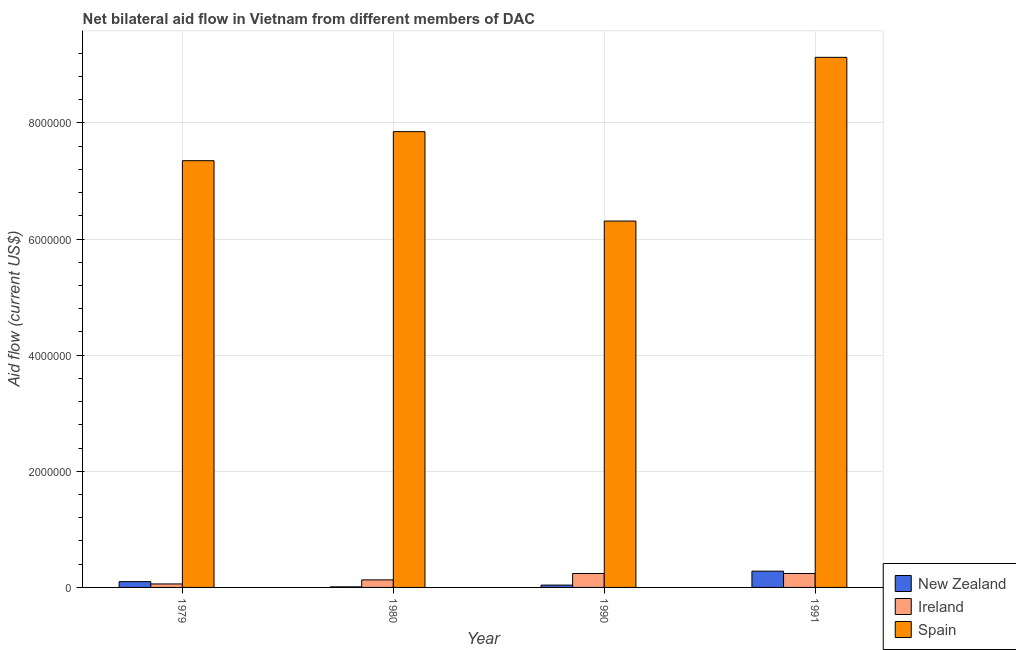What is the label of the 1st group of bars from the left?
Ensure brevity in your answer.  1979. In how many cases, is the number of bars for a given year not equal to the number of legend labels?
Your answer should be very brief. 0. What is the amount of aid provided by new zealand in 1979?
Provide a short and direct response. 1.00e+05. Across all years, what is the maximum amount of aid provided by ireland?
Give a very brief answer. 2.40e+05. Across all years, what is the minimum amount of aid provided by new zealand?
Provide a short and direct response. 10000. In which year was the amount of aid provided by spain minimum?
Offer a very short reply. 1990. What is the total amount of aid provided by ireland in the graph?
Your answer should be compact. 6.70e+05. What is the difference between the amount of aid provided by spain in 1990 and that in 1991?
Ensure brevity in your answer.  -2.82e+06. What is the difference between the amount of aid provided by new zealand in 1980 and the amount of aid provided by ireland in 1990?
Make the answer very short. -3.00e+04. What is the average amount of aid provided by ireland per year?
Offer a terse response. 1.68e+05. In how many years, is the amount of aid provided by ireland greater than 4000000 US$?
Make the answer very short. 0. Is the difference between the amount of aid provided by spain in 1979 and 1980 greater than the difference between the amount of aid provided by ireland in 1979 and 1980?
Offer a very short reply. No. What is the difference between the highest and the second highest amount of aid provided by ireland?
Your answer should be very brief. 0. What is the difference between the highest and the lowest amount of aid provided by spain?
Your answer should be very brief. 2.82e+06. What does the 2nd bar from the left in 1980 represents?
Your response must be concise. Ireland. What does the 2nd bar from the right in 1979 represents?
Ensure brevity in your answer.  Ireland. Is it the case that in every year, the sum of the amount of aid provided by new zealand and amount of aid provided by ireland is greater than the amount of aid provided by spain?
Offer a terse response. No. Are all the bars in the graph horizontal?
Provide a succinct answer. No. Are the values on the major ticks of Y-axis written in scientific E-notation?
Provide a short and direct response. No. Does the graph contain any zero values?
Your answer should be very brief. No. Where does the legend appear in the graph?
Your answer should be very brief. Bottom right. How are the legend labels stacked?
Your answer should be compact. Vertical. What is the title of the graph?
Ensure brevity in your answer.  Net bilateral aid flow in Vietnam from different members of DAC. Does "Social Protection" appear as one of the legend labels in the graph?
Give a very brief answer. No. What is the label or title of the X-axis?
Your answer should be very brief. Year. What is the Aid flow (current US$) of Ireland in 1979?
Offer a terse response. 6.00e+04. What is the Aid flow (current US$) in Spain in 1979?
Offer a very short reply. 7.35e+06. What is the Aid flow (current US$) in Spain in 1980?
Your answer should be compact. 7.85e+06. What is the Aid flow (current US$) of Ireland in 1990?
Offer a very short reply. 2.40e+05. What is the Aid flow (current US$) of Spain in 1990?
Your response must be concise. 6.31e+06. What is the Aid flow (current US$) of New Zealand in 1991?
Give a very brief answer. 2.80e+05. What is the Aid flow (current US$) of Ireland in 1991?
Offer a terse response. 2.40e+05. What is the Aid flow (current US$) of Spain in 1991?
Provide a succinct answer. 9.13e+06. Across all years, what is the maximum Aid flow (current US$) of New Zealand?
Offer a very short reply. 2.80e+05. Across all years, what is the maximum Aid flow (current US$) in Ireland?
Your answer should be compact. 2.40e+05. Across all years, what is the maximum Aid flow (current US$) of Spain?
Provide a short and direct response. 9.13e+06. Across all years, what is the minimum Aid flow (current US$) of Spain?
Make the answer very short. 6.31e+06. What is the total Aid flow (current US$) of Ireland in the graph?
Ensure brevity in your answer.  6.70e+05. What is the total Aid flow (current US$) in Spain in the graph?
Your answer should be compact. 3.06e+07. What is the difference between the Aid flow (current US$) of Spain in 1979 and that in 1980?
Offer a terse response. -5.00e+05. What is the difference between the Aid flow (current US$) in New Zealand in 1979 and that in 1990?
Provide a succinct answer. 6.00e+04. What is the difference between the Aid flow (current US$) of Spain in 1979 and that in 1990?
Offer a very short reply. 1.04e+06. What is the difference between the Aid flow (current US$) in Spain in 1979 and that in 1991?
Keep it short and to the point. -1.78e+06. What is the difference between the Aid flow (current US$) in Ireland in 1980 and that in 1990?
Make the answer very short. -1.10e+05. What is the difference between the Aid flow (current US$) of Spain in 1980 and that in 1990?
Offer a terse response. 1.54e+06. What is the difference between the Aid flow (current US$) in New Zealand in 1980 and that in 1991?
Your response must be concise. -2.70e+05. What is the difference between the Aid flow (current US$) in Ireland in 1980 and that in 1991?
Make the answer very short. -1.10e+05. What is the difference between the Aid flow (current US$) of Spain in 1980 and that in 1991?
Your answer should be very brief. -1.28e+06. What is the difference between the Aid flow (current US$) of Spain in 1990 and that in 1991?
Make the answer very short. -2.82e+06. What is the difference between the Aid flow (current US$) of New Zealand in 1979 and the Aid flow (current US$) of Spain in 1980?
Your answer should be compact. -7.75e+06. What is the difference between the Aid flow (current US$) in Ireland in 1979 and the Aid flow (current US$) in Spain in 1980?
Provide a succinct answer. -7.79e+06. What is the difference between the Aid flow (current US$) of New Zealand in 1979 and the Aid flow (current US$) of Spain in 1990?
Offer a very short reply. -6.21e+06. What is the difference between the Aid flow (current US$) in Ireland in 1979 and the Aid flow (current US$) in Spain in 1990?
Keep it short and to the point. -6.25e+06. What is the difference between the Aid flow (current US$) of New Zealand in 1979 and the Aid flow (current US$) of Spain in 1991?
Provide a short and direct response. -9.03e+06. What is the difference between the Aid flow (current US$) of Ireland in 1979 and the Aid flow (current US$) of Spain in 1991?
Give a very brief answer. -9.07e+06. What is the difference between the Aid flow (current US$) of New Zealand in 1980 and the Aid flow (current US$) of Spain in 1990?
Offer a terse response. -6.30e+06. What is the difference between the Aid flow (current US$) of Ireland in 1980 and the Aid flow (current US$) of Spain in 1990?
Keep it short and to the point. -6.18e+06. What is the difference between the Aid flow (current US$) in New Zealand in 1980 and the Aid flow (current US$) in Ireland in 1991?
Keep it short and to the point. -2.30e+05. What is the difference between the Aid flow (current US$) of New Zealand in 1980 and the Aid flow (current US$) of Spain in 1991?
Offer a very short reply. -9.12e+06. What is the difference between the Aid flow (current US$) of Ireland in 1980 and the Aid flow (current US$) of Spain in 1991?
Offer a terse response. -9.00e+06. What is the difference between the Aid flow (current US$) in New Zealand in 1990 and the Aid flow (current US$) in Ireland in 1991?
Ensure brevity in your answer.  -2.00e+05. What is the difference between the Aid flow (current US$) in New Zealand in 1990 and the Aid flow (current US$) in Spain in 1991?
Make the answer very short. -9.09e+06. What is the difference between the Aid flow (current US$) in Ireland in 1990 and the Aid flow (current US$) in Spain in 1991?
Ensure brevity in your answer.  -8.89e+06. What is the average Aid flow (current US$) of New Zealand per year?
Give a very brief answer. 1.08e+05. What is the average Aid flow (current US$) of Ireland per year?
Your answer should be very brief. 1.68e+05. What is the average Aid flow (current US$) of Spain per year?
Make the answer very short. 7.66e+06. In the year 1979, what is the difference between the Aid flow (current US$) of New Zealand and Aid flow (current US$) of Ireland?
Make the answer very short. 4.00e+04. In the year 1979, what is the difference between the Aid flow (current US$) of New Zealand and Aid flow (current US$) of Spain?
Keep it short and to the point. -7.25e+06. In the year 1979, what is the difference between the Aid flow (current US$) in Ireland and Aid flow (current US$) in Spain?
Offer a very short reply. -7.29e+06. In the year 1980, what is the difference between the Aid flow (current US$) of New Zealand and Aid flow (current US$) of Ireland?
Offer a very short reply. -1.20e+05. In the year 1980, what is the difference between the Aid flow (current US$) in New Zealand and Aid flow (current US$) in Spain?
Ensure brevity in your answer.  -7.84e+06. In the year 1980, what is the difference between the Aid flow (current US$) in Ireland and Aid flow (current US$) in Spain?
Provide a short and direct response. -7.72e+06. In the year 1990, what is the difference between the Aid flow (current US$) in New Zealand and Aid flow (current US$) in Ireland?
Offer a very short reply. -2.00e+05. In the year 1990, what is the difference between the Aid flow (current US$) in New Zealand and Aid flow (current US$) in Spain?
Ensure brevity in your answer.  -6.27e+06. In the year 1990, what is the difference between the Aid flow (current US$) in Ireland and Aid flow (current US$) in Spain?
Offer a very short reply. -6.07e+06. In the year 1991, what is the difference between the Aid flow (current US$) in New Zealand and Aid flow (current US$) in Spain?
Your response must be concise. -8.85e+06. In the year 1991, what is the difference between the Aid flow (current US$) in Ireland and Aid flow (current US$) in Spain?
Give a very brief answer. -8.89e+06. What is the ratio of the Aid flow (current US$) in Ireland in 1979 to that in 1980?
Provide a short and direct response. 0.46. What is the ratio of the Aid flow (current US$) of Spain in 1979 to that in 1980?
Offer a very short reply. 0.94. What is the ratio of the Aid flow (current US$) of Spain in 1979 to that in 1990?
Provide a succinct answer. 1.16. What is the ratio of the Aid flow (current US$) in New Zealand in 1979 to that in 1991?
Your response must be concise. 0.36. What is the ratio of the Aid flow (current US$) of Spain in 1979 to that in 1991?
Give a very brief answer. 0.81. What is the ratio of the Aid flow (current US$) of Ireland in 1980 to that in 1990?
Give a very brief answer. 0.54. What is the ratio of the Aid flow (current US$) in Spain in 1980 to that in 1990?
Make the answer very short. 1.24. What is the ratio of the Aid flow (current US$) in New Zealand in 1980 to that in 1991?
Provide a succinct answer. 0.04. What is the ratio of the Aid flow (current US$) in Ireland in 1980 to that in 1991?
Keep it short and to the point. 0.54. What is the ratio of the Aid flow (current US$) of Spain in 1980 to that in 1991?
Your response must be concise. 0.86. What is the ratio of the Aid flow (current US$) in New Zealand in 1990 to that in 1991?
Give a very brief answer. 0.14. What is the ratio of the Aid flow (current US$) in Spain in 1990 to that in 1991?
Provide a short and direct response. 0.69. What is the difference between the highest and the second highest Aid flow (current US$) of Ireland?
Make the answer very short. 0. What is the difference between the highest and the second highest Aid flow (current US$) in Spain?
Offer a very short reply. 1.28e+06. What is the difference between the highest and the lowest Aid flow (current US$) of Spain?
Your answer should be very brief. 2.82e+06. 